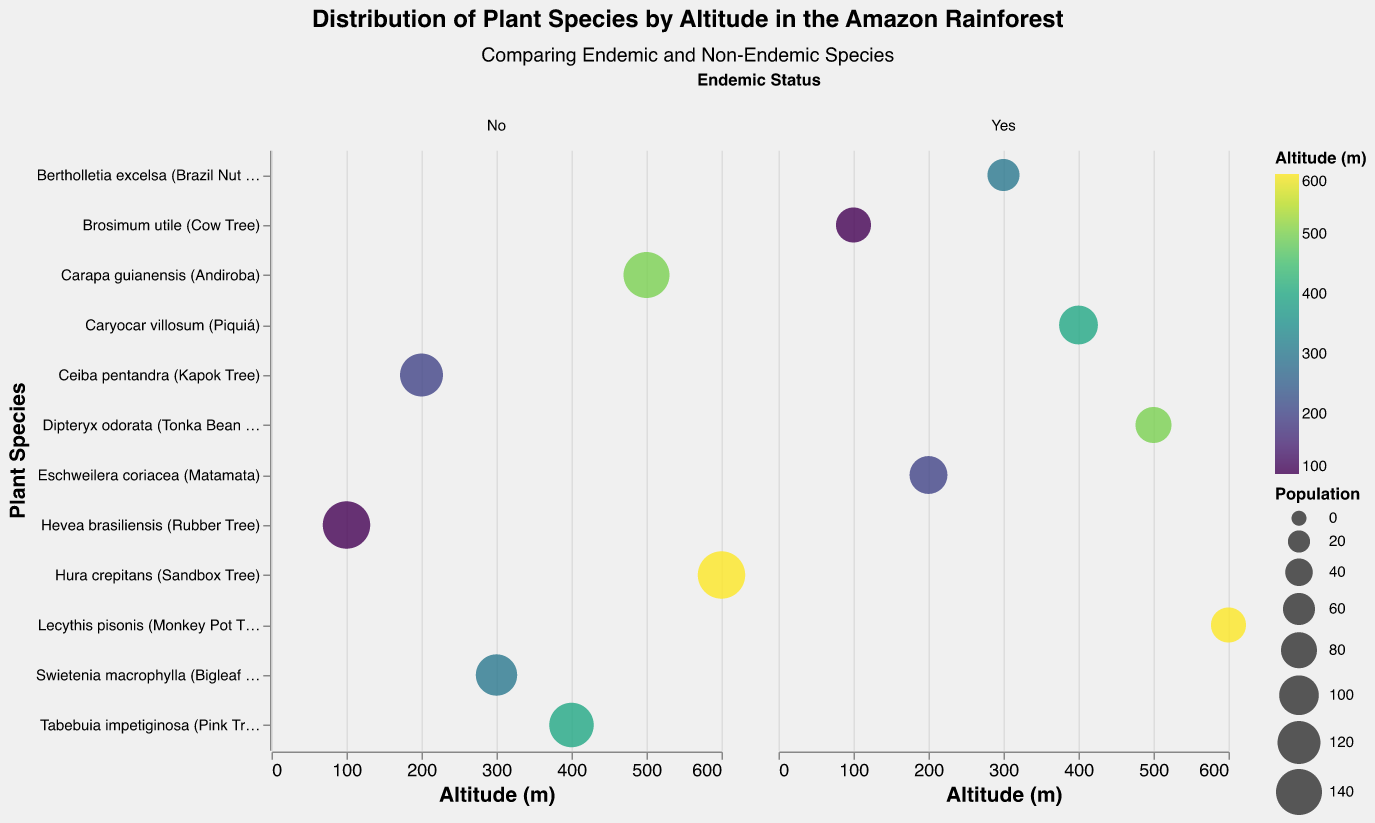Which plant species has the largest population at 100 meters altitude? The Rubber Tree and Cow Tree are the only species at 100 meters altitude. Comparing their populations, Rubber Tree has 150 and Cow Tree has 75. Thus, Rubber Tree has the largest population.
Answer: Hevea brasiliensis (Rubber Tree) How many plant species are documented in this figure at 200 meters altitude? There are two plant species at 200 meters altitude: Kapok Tree and Matamata.
Answer: 2 What is the average population of the endemic species at 400 meters altitude? The endemic species at 400 meters is Piquiá which has a population of 95. Since there's only one endemic species at this altitude, the average population is 95.
Answer: 95 Which species is distributed at the highest altitude and is it endemic or non-endemic? The species at 600 meters altitude are Sandbox Tree and Monkey Pot Tree. The Sandbox Tree is non-endemic, and the Monkey Pot Tree is endemic.
Answer: Hura crepitans (Sandbox Tree), Non-Endemic At 500 meters altitude, which species has a greater population and by how much? The species at 500 meters are Andiroba (140) and Tonka Bean Tree (80). The difference in their population is 140 - 80 = 60.
Answer: Carapa guianensis (Andiroba), 60 Is the population of endemic species higher at 300 meters altitude or 500 meters altitude? At 300 meters, the endemic species is Brazil Nut Tree with a population of 60. At 500 meters, the endemic species is Tonka Bean Tree with a population of 80. Therefore, the population is higher at 500 meters.
Answer: 500 meters Compare the total population of non-endemic species to the total population of endemic species. Which group has a higher total population? Non-endemic species populations are 150, 120, 110, 130, 140, and 150, summing to 800. Endemic species populations are 75, 90, 60, 95, 80, and 75, summing to 475. Non-endemic species have a higher total population.
Answer: Non-Endemic, 800 What colors represent the lowest and highest altitudes on the chart? Based on the color scheme, the lowest altitude (100 meters) and highest altitude (600 meters) will have contrasting colors on a viridis scale. The exact hues would be a dark purple for the lowest and a bright yellow for the highest.
Answer: Dark purple, Bright yellow 